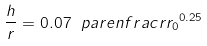Convert formula to latex. <formula><loc_0><loc_0><loc_500><loc_500>\frac { h } { r } = 0 . 0 7 \ p a r e n f r a c { r } { r _ { 0 } } ^ { 0 . 2 5 }</formula> 